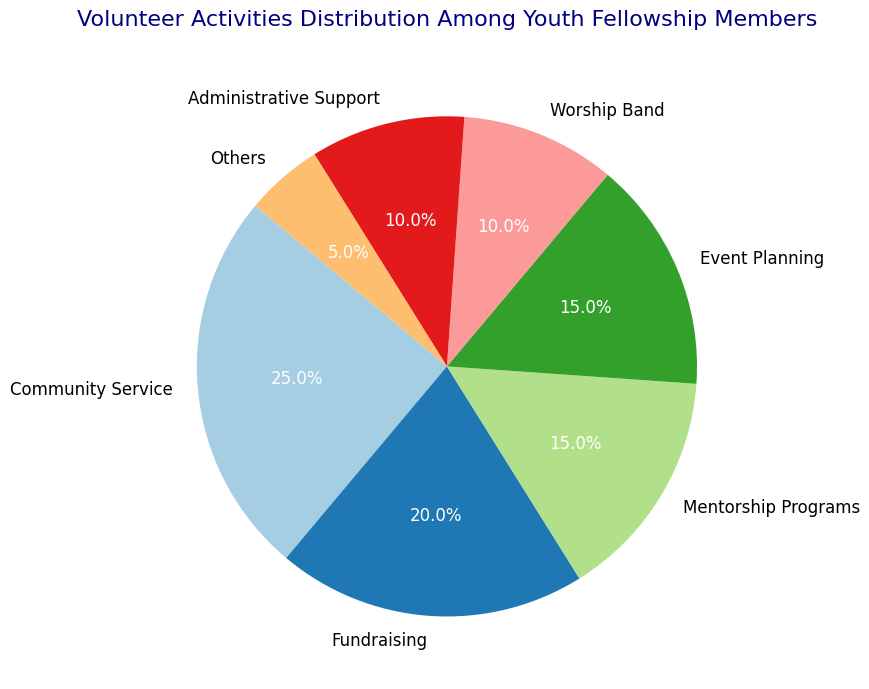Which activity has the highest percentage? Look at the slices of the pie chart and identify the one with the largest slice. The label and percentage for this activity are "Community Service 25%".
Answer: Community Service Which activity has the lowest percentage? Look at the slices of the pie chart and identify the one with the smallest slice. The label and percentage for this activity are "Others 5%".
Answer: Others Compare the percentage between Fundraising and Worship Band, which one is larger and by how much? From the pie chart, Fundraising has 20% and Worship Band has 10%. The difference is calculated as 20% - 10%.
Answer: Fundraising by 10% What is the combined percentage of Mentorship Programs and Event Planning? Check the pie chart for the percentages of both Mentorship Programs (15%) and Event Planning (15%) and sum them up: 15% + 15%.
Answer: 30% What percentage of activities are for Community Service, Fundraising, and Worship Band combined? Sum the percentages for Community Service (25%), Fundraising (20%), and Worship Band (10%): 25% + 20% + 10%.
Answer: 55% Which two activities have the same percentage? Identify the slices that have the same size and percentage labels. Mentorship Programs and Event Planning both have 15%.
Answer: Mentorship Programs and Event Planning Compare the percentage of Administrative Support to that of Worship Band. Which one is smaller? Identify the percentages for Administrative Support (10%) and Worship Band (10%). Both are the same; hence, neither is smaller.
Answer: Neither, they are equal How much more is the percentage for Community Service compared to Administrative Support? Subtract the percentage of Administrative Support (10%) from Community Service (25%): 25% – 10%.
Answer: 15% What is the difference in percentage between the largest and the smallest activity? Identify the largest percentage (Community Service 25%) and the smallest (Others 5%) and find the difference: 25% - 5%.
Answer: 20% If an additional category with 5% was added, what would be the total percentage of all activities? Sum all the current percentages: 25% + 20% + 15% + 15% + 10% + 10% + 5% = 100%, then add the new category: 100% + 5%.
Answer: 105% 